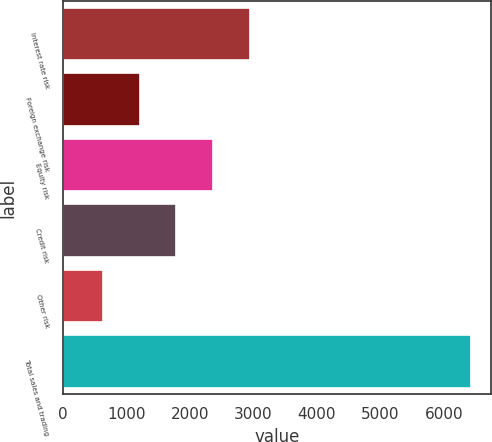Convert chart. <chart><loc_0><loc_0><loc_500><loc_500><bar_chart><fcel>Interest rate risk<fcel>Foreign exchange risk<fcel>Equity risk<fcel>Credit risk<fcel>Other risk<fcel>Total sales and trading<nl><fcel>2948.8<fcel>1209.7<fcel>2369.1<fcel>1789.4<fcel>630<fcel>6427<nl></chart> 